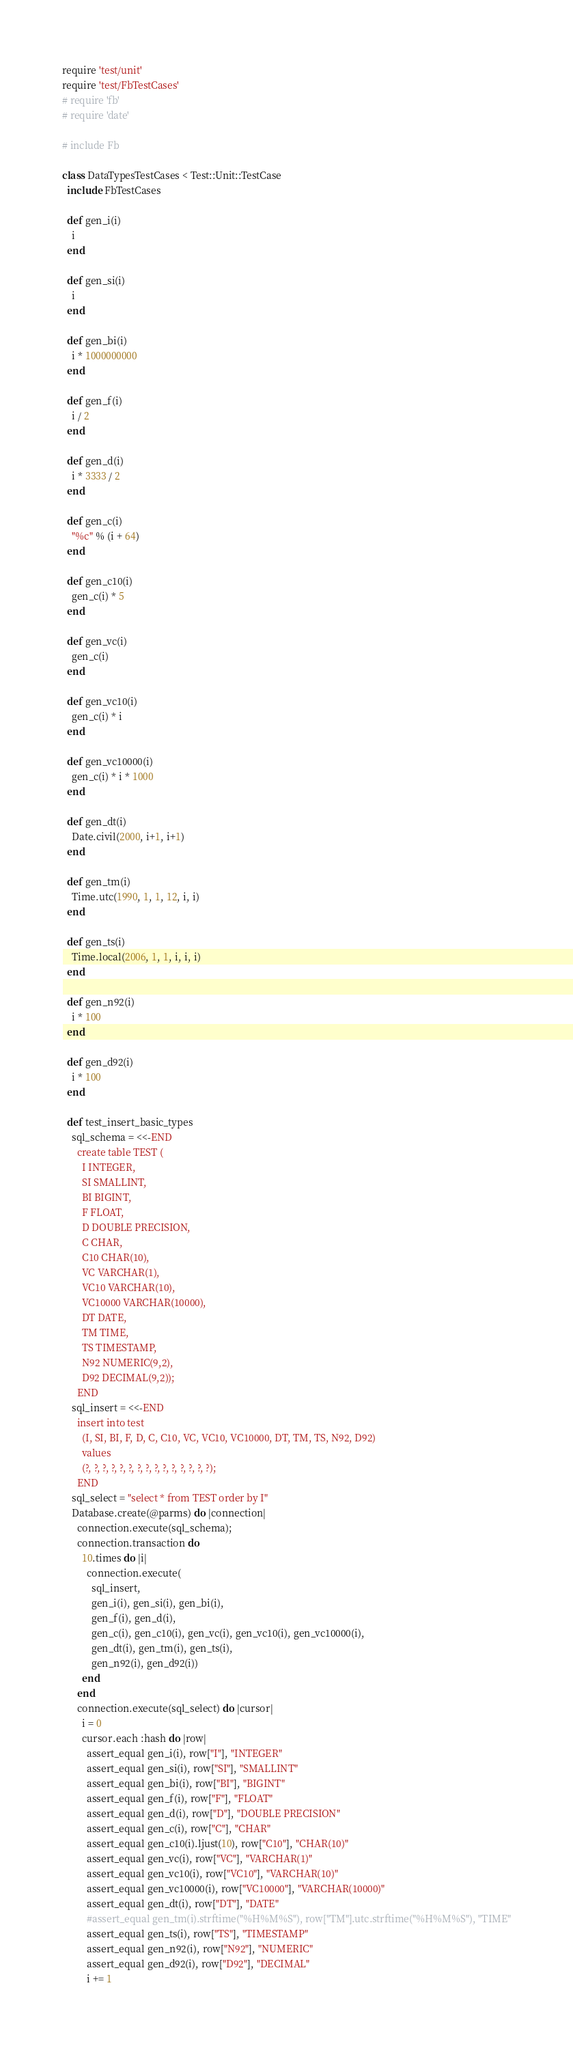<code> <loc_0><loc_0><loc_500><loc_500><_Ruby_>require 'test/unit'
require 'test/FbTestCases'
# require 'fb'
# require 'date'

# include Fb

class DataTypesTestCases < Test::Unit::TestCase
  include FbTestCases
  
  def gen_i(i)
    i
  end
  
  def gen_si(i)
    i
  end
  
  def gen_bi(i)
    i * 1000000000
  end
  
  def gen_f(i)
    i / 2
  end
  
  def gen_d(i)
    i * 3333 / 2
  end
  
  def gen_c(i)
    "%c" % (i + 64)
  end
  
  def gen_c10(i)
    gen_c(i) * 5
  end
  
  def gen_vc(i)
    gen_c(i)
  end
  
  def gen_vc10(i)
    gen_c(i) * i
  end
  
  def gen_vc10000(i)
    gen_c(i) * i * 1000
  end
  
  def gen_dt(i)
    Date.civil(2000, i+1, i+1)
  end
  
  def gen_tm(i)
    Time.utc(1990, 1, 1, 12, i, i)
  end
  
  def gen_ts(i)
    Time.local(2006, 1, 1, i, i, i)
  end

  def gen_n92(i)
    i * 100
  end

  def gen_d92(i)
    i * 100
  end

  def test_insert_basic_types
    sql_schema = <<-END
      create table TEST (
        I INTEGER,
        SI SMALLINT,
        BI BIGINT,
        F FLOAT, 
        D DOUBLE PRECISION,
        C CHAR,
        C10 CHAR(10),
        VC VARCHAR(1),
        VC10 VARCHAR(10),
        VC10000 VARCHAR(10000),
        DT DATE,
        TM TIME,
        TS TIMESTAMP,
        N92 NUMERIC(9,2),
        D92 DECIMAL(9,2));
      END
    sql_insert = <<-END
      insert into test 
        (I, SI, BI, F, D, C, C10, VC, VC10, VC10000, DT, TM, TS, N92, D92) 
        values
        (?, ?, ?, ?, ?, ?, ?, ?, ?, ?, ?, ?, ?, ?, ?);
      END
    sql_select = "select * from TEST order by I"
    Database.create(@parms) do |connection|
      connection.execute(sql_schema);
      connection.transaction do
        10.times do |i|
          connection.execute(
            sql_insert, 
            gen_i(i), gen_si(i), gen_bi(i),
            gen_f(i), gen_d(i),
            gen_c(i), gen_c10(i), gen_vc(i), gen_vc10(i), gen_vc10000(i), 
            gen_dt(i), gen_tm(i), gen_ts(i),
            gen_n92(i), gen_d92(i))
        end
      end
      connection.execute(sql_select) do |cursor|
        i = 0
        cursor.each :hash do |row|
          assert_equal gen_i(i), row["I"], "INTEGER"
          assert_equal gen_si(i), row["SI"], "SMALLINT"
          assert_equal gen_bi(i), row["BI"], "BIGINT"
          assert_equal gen_f(i), row["F"], "FLOAT"
          assert_equal gen_d(i), row["D"], "DOUBLE PRECISION"
          assert_equal gen_c(i), row["C"], "CHAR"
          assert_equal gen_c10(i).ljust(10), row["C10"], "CHAR(10)"
          assert_equal gen_vc(i), row["VC"], "VARCHAR(1)"
          assert_equal gen_vc10(i), row["VC10"], "VARCHAR(10)"
          assert_equal gen_vc10000(i), row["VC10000"], "VARCHAR(10000)"
          assert_equal gen_dt(i), row["DT"], "DATE"
          #assert_equal gen_tm(i).strftime("%H%M%S"), row["TM"].utc.strftime("%H%M%S"), "TIME"
          assert_equal gen_ts(i), row["TS"], "TIMESTAMP"
          assert_equal gen_n92(i), row["N92"], "NUMERIC"
          assert_equal gen_d92(i), row["D92"], "DECIMAL"
          i += 1</code> 